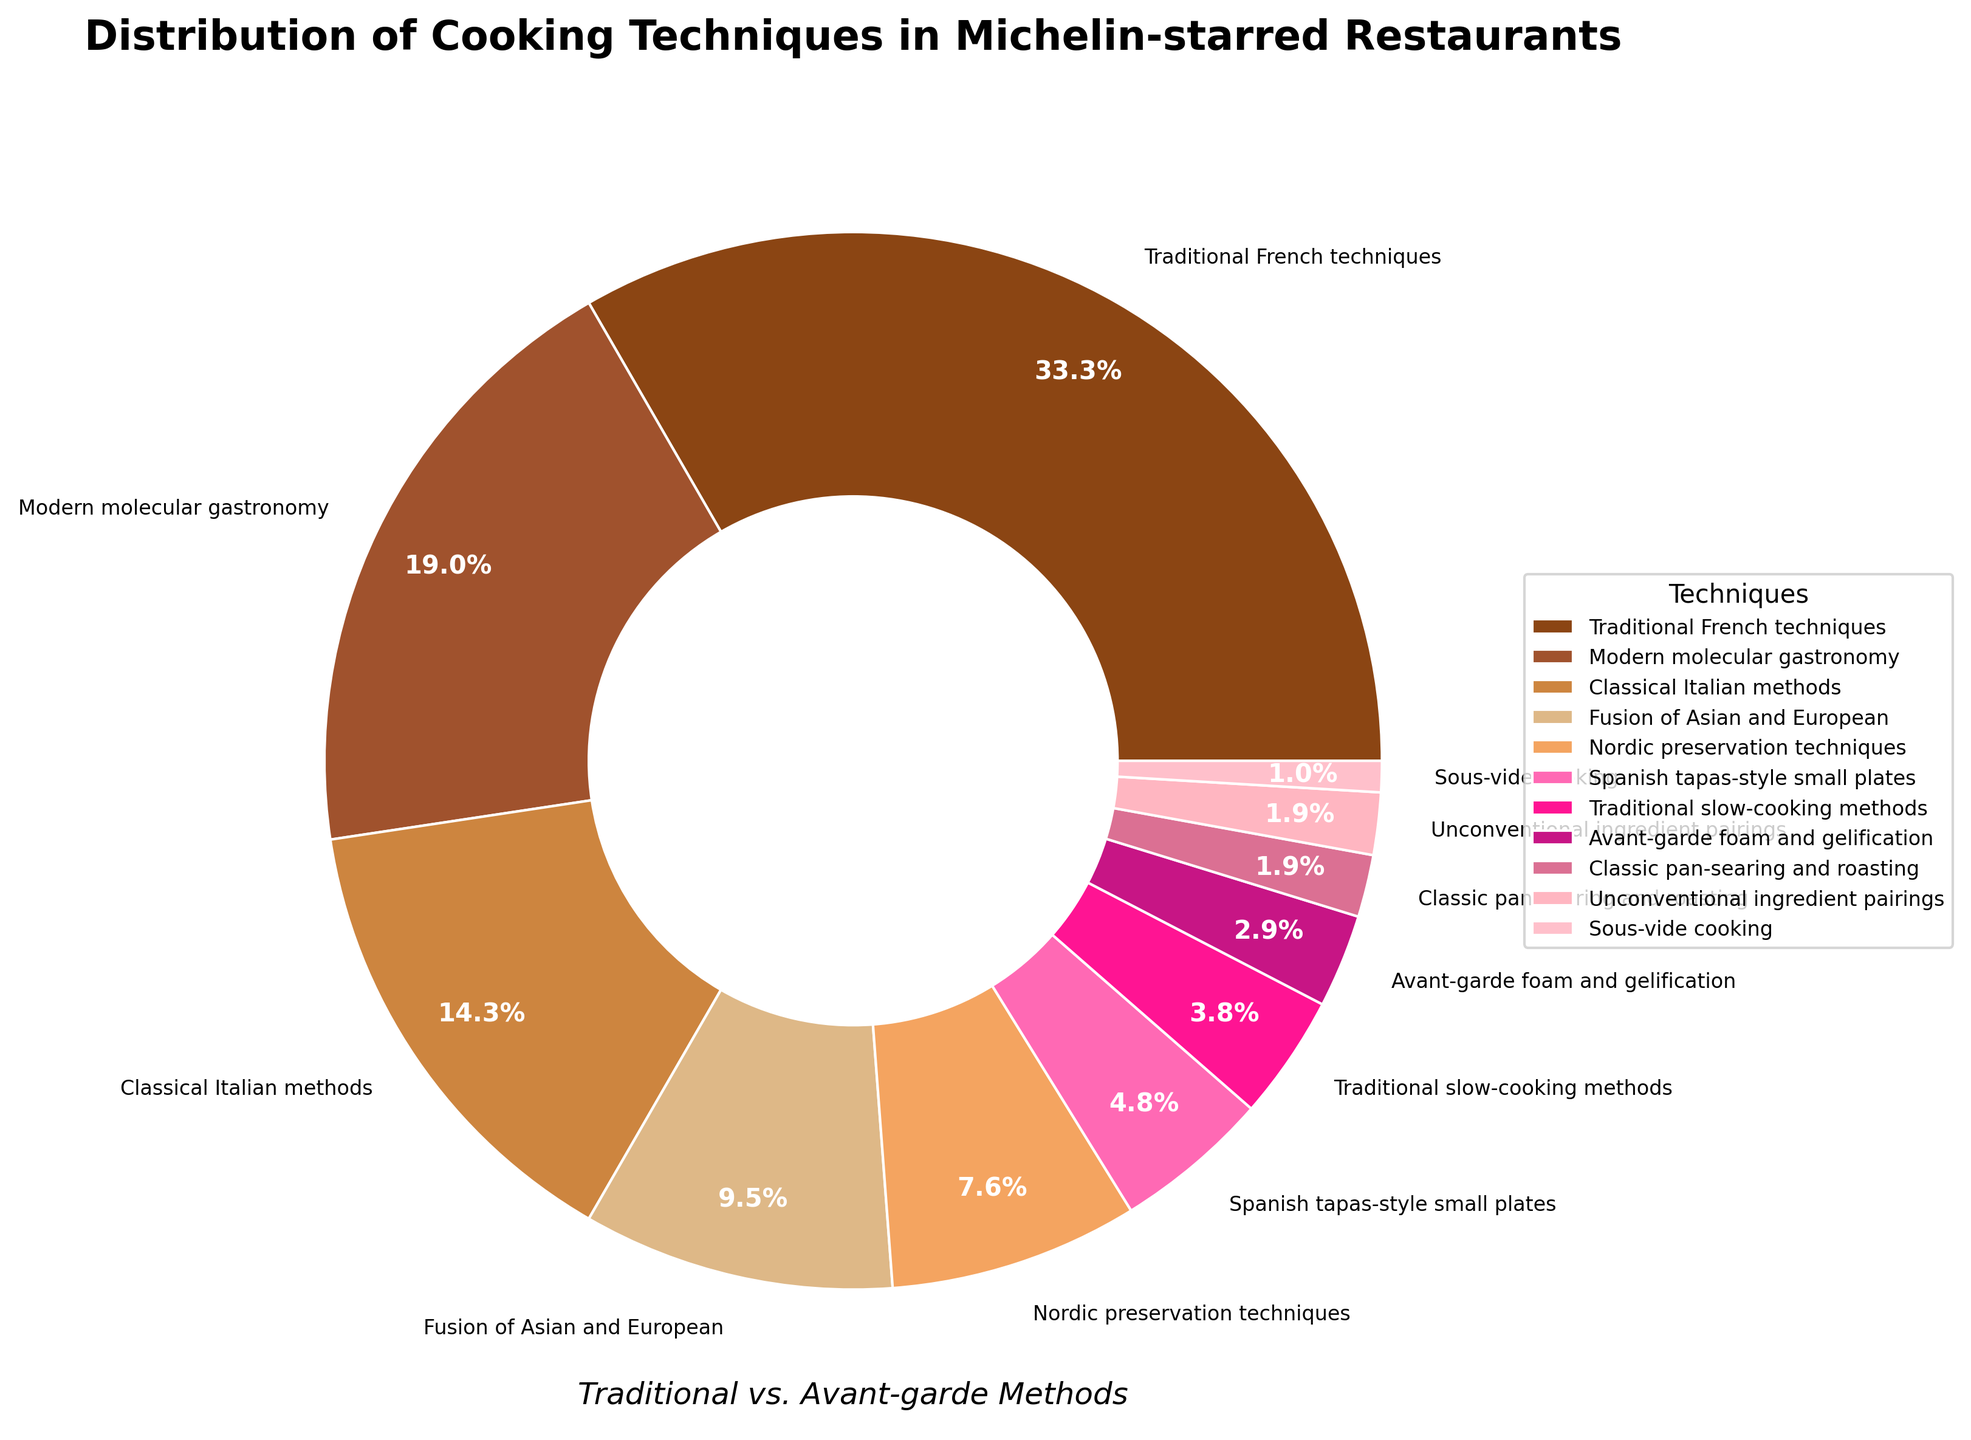Which technique holds the largest percentage in the distribution of cooking techniques? The chart shows the percentages of each cooking technique. The largest wedge is labeled 'Traditional French techniques' at 35%.
Answer: Traditional French techniques How much larger is the percentage of Classical Italian techniques compared to Fusion of Asian and European techniques? According to the chart, Classical Italian methods are 15% while Fusion of Asian and European is 10%. The difference is 15% - 10% = 5%.
Answer: 5% If you combine all avant-garde techniques, what is their total percentage? Avant-garde techniques can be identified as Modern molecular gastronomy (20%), Avant-garde foam and gelification (3%), Unconventional ingredient pairings (2%), and Sous-vide cooking (1%). Summing them: 20% + 3% + 2% + 1% = 26%.
Answer: 26% Which two techniques have the smallest representation in the pie chart? The smallest wedges represent Classic pan-searing and roasting (2%) and Sous-vide cooking (1%).
Answer: Classic pan-searing and roasting, Sous-vide cooking How does the representation of Nordic preservation techniques compare to Spanish tapas-style small plates? Nordic preservation techniques have a percentage of 8%, while Spanish tapas-style small plates have 5%. Nordic preservation techniques are larger by 8% - 5% = 3%.
Answer: 3% Is the total percentage of traditional techniques more than 50%? The traditional techniques include Traditional French techniques (35%), Classical Italian methods (15%), Traditional slow-cooking methods (4%), Classic pan-searing and roasting (2%). Summing them: 35% + 15% + 4% + 2% = 56%. 56% is more than 50%.
Answer: Yes Visualize and compare the color representation of techniques grouped by similar hues in the pie chart. Which group among the traditional categories seems most dominant visually? Traditional categories have shades of brown. The largest wedge in these hues represents Traditional French techniques, which is 35% of the chart.
Answer: Traditional French techniques What proportion of the chart is made up of techniques with a percentage less than or equal to 10%? Techniques less than or equal to 10% are: Fusion of Asian and European (10%), Nordic preservation techniques (8%), Spanish tapas-style small plates (5%), Traditional slow-cooking methods (4%), Avant-garde foam and gelification (3%), Classic pan-searing and roasting (2%), Unconventional ingredient pairings (2%), and Sous-vide cooking (1%). Total: 10% + 8% + 5% + 4% + 3% + 2% + 2% + 1% = 35%.
Answer: 35% Which technique has almost half the representation of Modern molecular gastronomy? Modern molecular gastronomy is 20%. The technique closest to half of this value is Classical Italian methods at 15%.
Answer: Classical Italian methods 